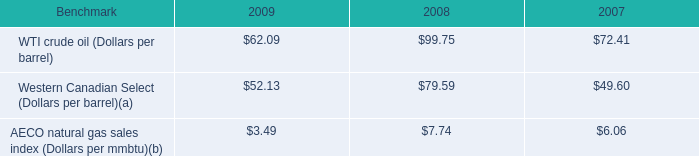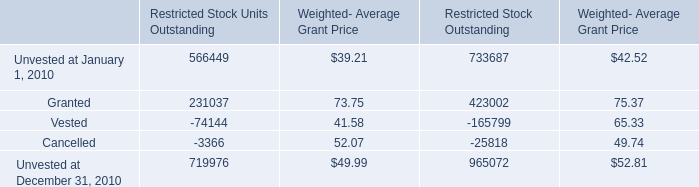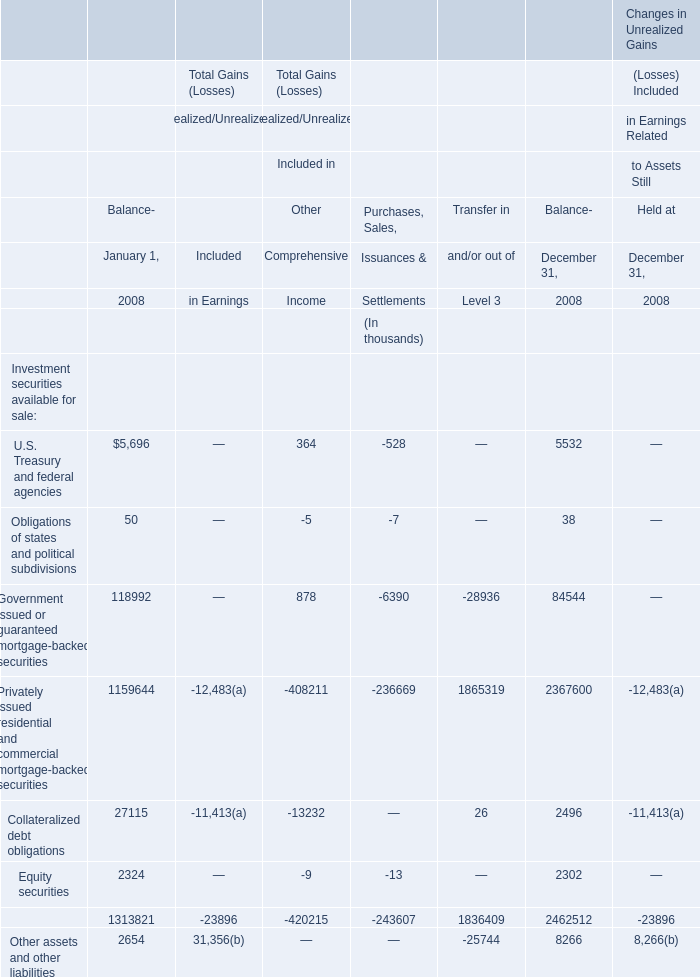What is the sum of U.S. Treasury and federal agencies,Obligations of states and political subdivisions and Government issued or guaranteed mortgage-backed securities for Included in Other Comprehensive Income? (in thousand) 
Computations: ((364 - 5) + 878)
Answer: 1237.0. 